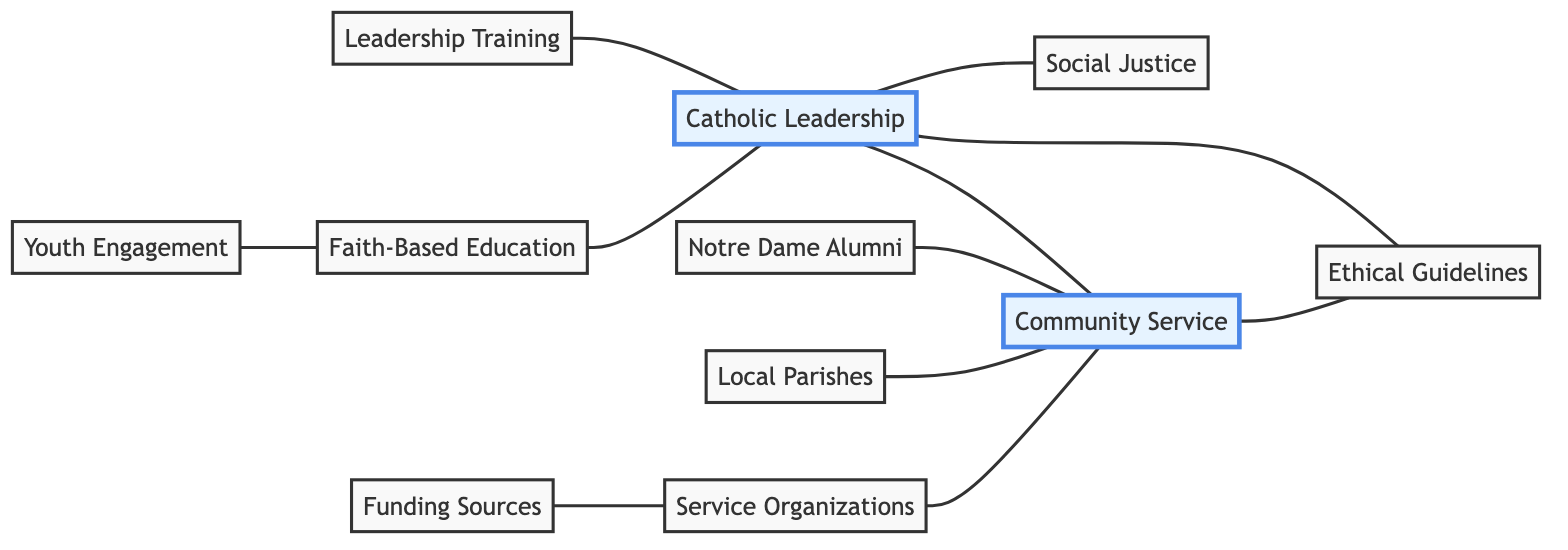What is the total number of nodes in the graph? By counting all the distinct elements in the "nodes" section of the data, we have a total of 11 nodes.
Answer: 11 Which node is directly connected to Community Service? The edges that connect to the Community Service node indicate it is directly linked to Social Justice, Notre Dame Alumni Network, Local Parishes, Service Organizations, and Ethical Guidelines, thus naming all connected nodes.
Answer: Social Justice, Notre Dame Alumni Network, Local Parishes, Service Organizations, Ethical Guidelines What relationship does Catholic Leadership have with Ethical Guidelines? The diagram indicates a direct connection (edge) between Catholic Leadership and Ethical Guidelines, demonstrating their relationship clearly.
Answer: Direct connection How many connections does the Faith-Based Education node have? Checking for edges that start or end at Faith-Based Education, we see there is one connection to Catholic Leadership, resulting in a total of 1 connection.
Answer: 1 Which node serves as a funding source for Service Organizations? The edge indicates that Funding Sources, for example, Knights of Columbus, connects directly to Service Organizations, revealing its role as funding.
Answer: Funding Sources What is the relationship between Youth Engagement and Faith-Based Education? The data shows that there is a direct connection from Youth Engagement to Faith-Based Education, indicating a relationship is present in the diagram.
Answer: Direct connection How many edge connections does the Local Parishes node have? Counting the edges starting from the Local Parishes, we find it connects to Community Service, leading us to conclude it has one edge.
Answer: 1 Which two nodes have the most connections leading towards Community Service? Analyzing the connections, we determine that Catholic Leadership and Local Parishes each connect directly to Community Service, making them the nodes with the most connections to this initiative.
Answer: Catholic Leadership, Local Parishes How does Leadership Training relate to Catholic Leadership? The graph shows a direct edge from Leadership Training to Catholic Leadership, showcasing the relationship where Leadership Training supports or strengthens Catholic Leadership.
Answer: Direct connection 